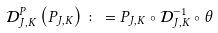<formula> <loc_0><loc_0><loc_500><loc_500>\mathcal { D } ^ { P } _ { J , K } \left ( P _ { J , K } \right ) \colon = P _ { J , K } \circ \mathcal { D } _ { J , K } ^ { - 1 } \circ \theta</formula> 